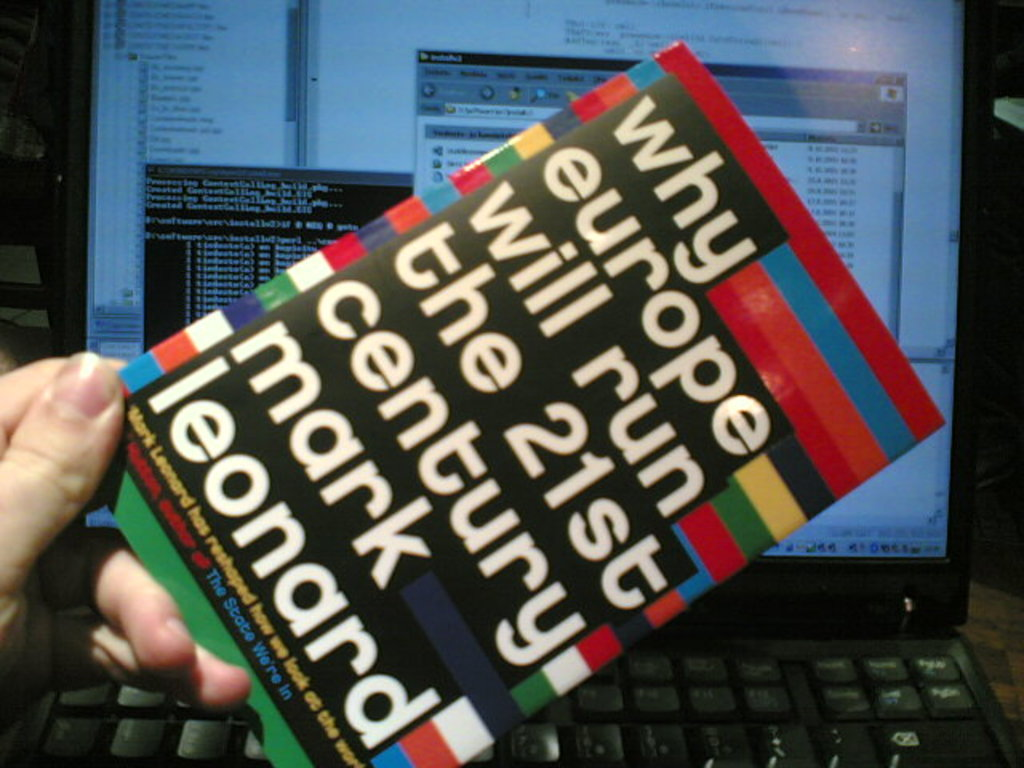Is there any significance to the way the book is being held or its positioning in the image? The focused manner in which the book is presented, with its cover fully visible and positioned prominently in front of a computer screen, can reflect the importance the holder places on the book's content and its central thesis about Europe's role. Could you provide an analysis on the visual design of the book's cover? The cover features a bold, multicolored design with stripes that could represent the diversity and unity of the European Union's member states, while the prominent placement of the title and author's name emphasizes the forward-looking message of the book. 